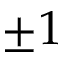Convert formula to latex. <formula><loc_0><loc_0><loc_500><loc_500>\pm 1</formula> 